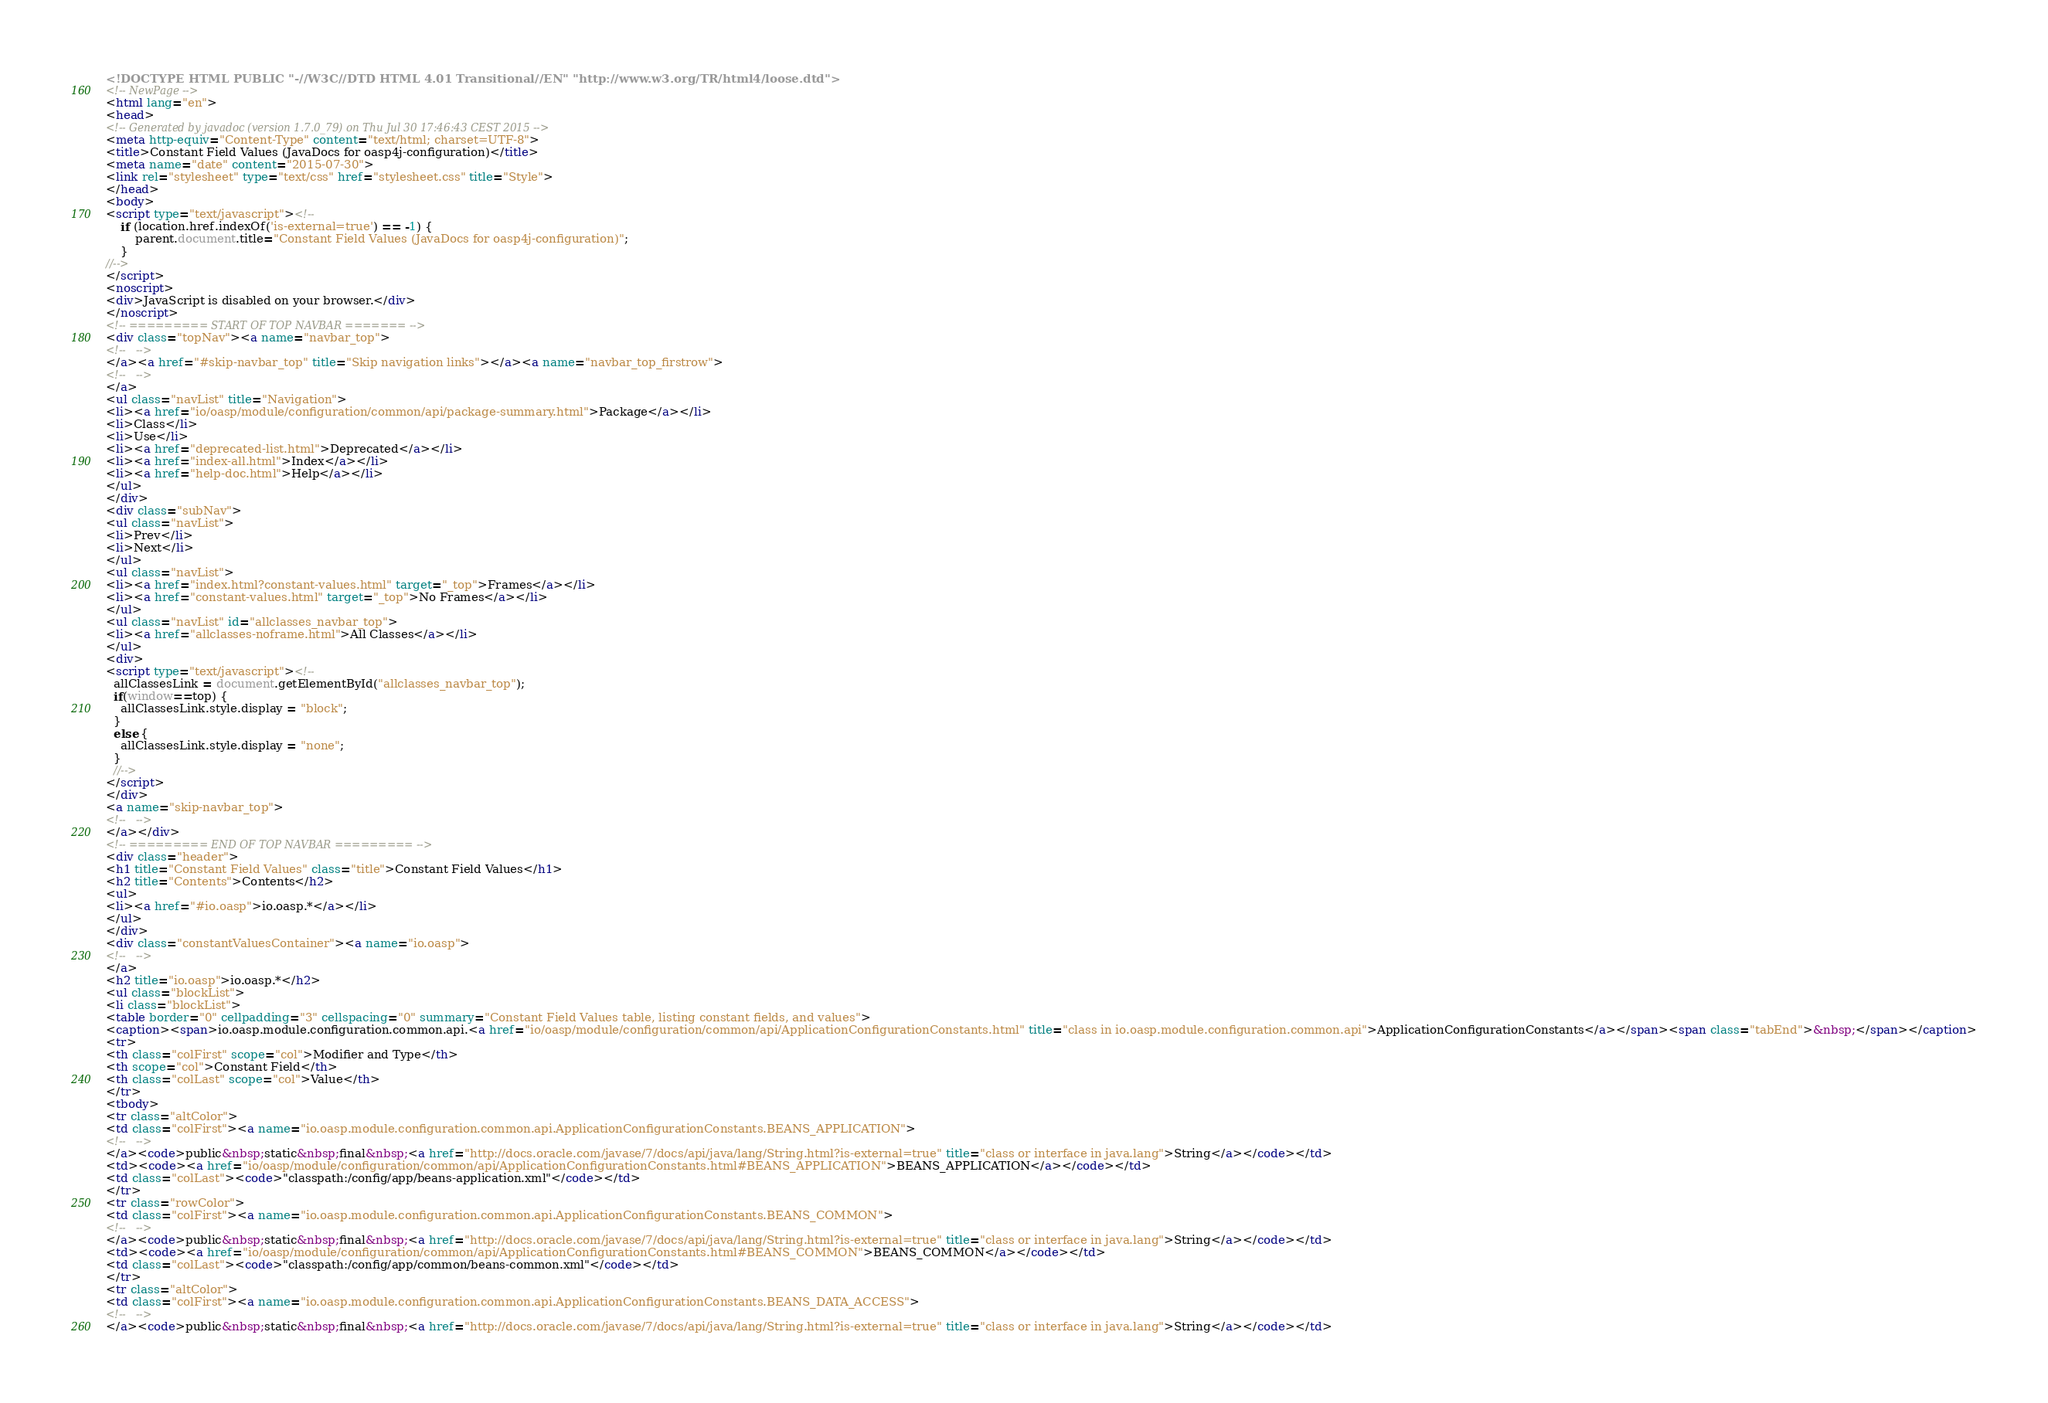Convert code to text. <code><loc_0><loc_0><loc_500><loc_500><_HTML_><!DOCTYPE HTML PUBLIC "-//W3C//DTD HTML 4.01 Transitional//EN" "http://www.w3.org/TR/html4/loose.dtd">
<!-- NewPage -->
<html lang="en">
<head>
<!-- Generated by javadoc (version 1.7.0_79) on Thu Jul 30 17:46:43 CEST 2015 -->
<meta http-equiv="Content-Type" content="text/html; charset=UTF-8">
<title>Constant Field Values (JavaDocs for oasp4j-configuration)</title>
<meta name="date" content="2015-07-30">
<link rel="stylesheet" type="text/css" href="stylesheet.css" title="Style">
</head>
<body>
<script type="text/javascript"><!--
    if (location.href.indexOf('is-external=true') == -1) {
        parent.document.title="Constant Field Values (JavaDocs for oasp4j-configuration)";
    }
//-->
</script>
<noscript>
<div>JavaScript is disabled on your browser.</div>
</noscript>
<!-- ========= START OF TOP NAVBAR ======= -->
<div class="topNav"><a name="navbar_top">
<!--   -->
</a><a href="#skip-navbar_top" title="Skip navigation links"></a><a name="navbar_top_firstrow">
<!--   -->
</a>
<ul class="navList" title="Navigation">
<li><a href="io/oasp/module/configuration/common/api/package-summary.html">Package</a></li>
<li>Class</li>
<li>Use</li>
<li><a href="deprecated-list.html">Deprecated</a></li>
<li><a href="index-all.html">Index</a></li>
<li><a href="help-doc.html">Help</a></li>
</ul>
</div>
<div class="subNav">
<ul class="navList">
<li>Prev</li>
<li>Next</li>
</ul>
<ul class="navList">
<li><a href="index.html?constant-values.html" target="_top">Frames</a></li>
<li><a href="constant-values.html" target="_top">No Frames</a></li>
</ul>
<ul class="navList" id="allclasses_navbar_top">
<li><a href="allclasses-noframe.html">All Classes</a></li>
</ul>
<div>
<script type="text/javascript"><!--
  allClassesLink = document.getElementById("allclasses_navbar_top");
  if(window==top) {
    allClassesLink.style.display = "block";
  }
  else {
    allClassesLink.style.display = "none";
  }
  //-->
</script>
</div>
<a name="skip-navbar_top">
<!--   -->
</a></div>
<!-- ========= END OF TOP NAVBAR ========= -->
<div class="header">
<h1 title="Constant Field Values" class="title">Constant Field Values</h1>
<h2 title="Contents">Contents</h2>
<ul>
<li><a href="#io.oasp">io.oasp.*</a></li>
</ul>
</div>
<div class="constantValuesContainer"><a name="io.oasp">
<!--   -->
</a>
<h2 title="io.oasp">io.oasp.*</h2>
<ul class="blockList">
<li class="blockList">
<table border="0" cellpadding="3" cellspacing="0" summary="Constant Field Values table, listing constant fields, and values">
<caption><span>io.oasp.module.configuration.common.api.<a href="io/oasp/module/configuration/common/api/ApplicationConfigurationConstants.html" title="class in io.oasp.module.configuration.common.api">ApplicationConfigurationConstants</a></span><span class="tabEnd">&nbsp;</span></caption>
<tr>
<th class="colFirst" scope="col">Modifier and Type</th>
<th scope="col">Constant Field</th>
<th class="colLast" scope="col">Value</th>
</tr>
<tbody>
<tr class="altColor">
<td class="colFirst"><a name="io.oasp.module.configuration.common.api.ApplicationConfigurationConstants.BEANS_APPLICATION">
<!--   -->
</a><code>public&nbsp;static&nbsp;final&nbsp;<a href="http://docs.oracle.com/javase/7/docs/api/java/lang/String.html?is-external=true" title="class or interface in java.lang">String</a></code></td>
<td><code><a href="io/oasp/module/configuration/common/api/ApplicationConfigurationConstants.html#BEANS_APPLICATION">BEANS_APPLICATION</a></code></td>
<td class="colLast"><code>"classpath:/config/app/beans-application.xml"</code></td>
</tr>
<tr class="rowColor">
<td class="colFirst"><a name="io.oasp.module.configuration.common.api.ApplicationConfigurationConstants.BEANS_COMMON">
<!--   -->
</a><code>public&nbsp;static&nbsp;final&nbsp;<a href="http://docs.oracle.com/javase/7/docs/api/java/lang/String.html?is-external=true" title="class or interface in java.lang">String</a></code></td>
<td><code><a href="io/oasp/module/configuration/common/api/ApplicationConfigurationConstants.html#BEANS_COMMON">BEANS_COMMON</a></code></td>
<td class="colLast"><code>"classpath:/config/app/common/beans-common.xml"</code></td>
</tr>
<tr class="altColor">
<td class="colFirst"><a name="io.oasp.module.configuration.common.api.ApplicationConfigurationConstants.BEANS_DATA_ACCESS">
<!--   -->
</a><code>public&nbsp;static&nbsp;final&nbsp;<a href="http://docs.oracle.com/javase/7/docs/api/java/lang/String.html?is-external=true" title="class or interface in java.lang">String</a></code></td></code> 